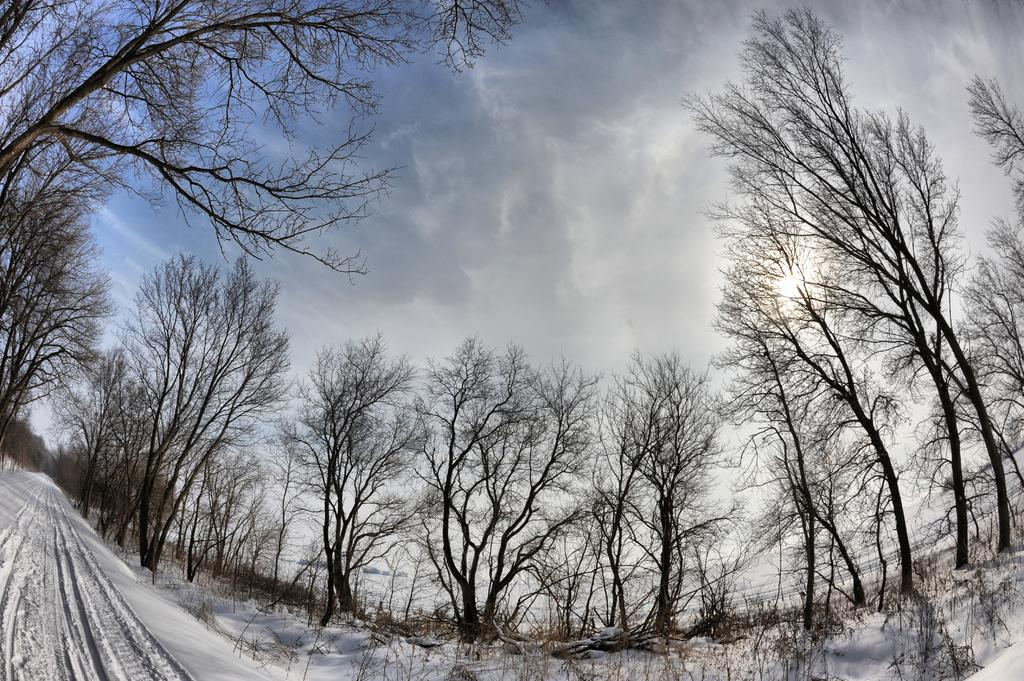What type of surface is visible in the image? There is a snow surface in the image. What can be seen on both sides of the snow surface? There are trees on both sides of the snow surface. How do the trees appear in the image? The trees appear to be dried. What is visible in the sky in the image? The sky is visible in the image, and clouds are present. What type of lettuce is being used to express anger in the image? There is no lettuce or expression of anger present in the image. 